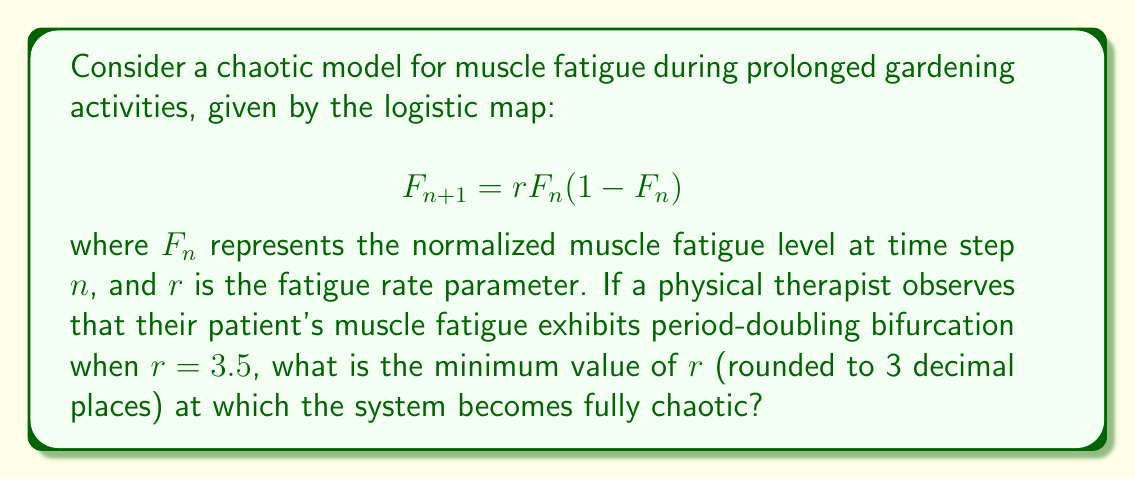Solve this math problem. To solve this problem, we need to understand the behavior of the logistic map and its transition to chaos:

1. The logistic map undergoes a series of period-doubling bifurcations as $r$ increases.
2. The period-doubling cascade eventually leads to chaos.
3. The transition to full chaos occurs at a specific value of $r$, known as the Feigenbaum point.

The Feigenbaum point for the logistic map has been calculated to high precision:

$$r_∞ ≈ 3.56994567187094490184200515138113453556...$$

This value represents the minimum $r$ at which the system becomes fully chaotic.

Rounding this value to 3 decimal places gives us 3.570.

It's worth noting that for $r = 3.5$, as mentioned in the question, the system is still in the period-doubling regime and not yet fully chaotic. This aligns with the observation of period-doubling bifurcation at that point.

For the physical therapist, this means that the patient's muscle fatigue during prolonged gardening activities would transition from predictable, periodic behavior to unpredictable, chaotic behavior as the fatigue rate parameter increases beyond this critical value.
Answer: 3.570 